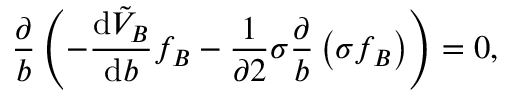Convert formula to latex. <formula><loc_0><loc_0><loc_500><loc_500>\frac { \partial } { b } \left ( - \frac { d \tilde { V } _ { B } } { d b } f _ { B } - \frac { 1 } { \partial 2 } \sigma \frac { \partial } { b } \left ( \sigma f _ { B } \right ) \right ) = 0 ,</formula> 